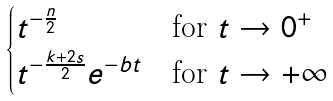<formula> <loc_0><loc_0><loc_500><loc_500>\begin{cases} t ^ { - \frac { n } { 2 } } & \text {for $t \to 0^{+}$} \\ t ^ { - \frac { k + 2 s } { 2 } } e ^ { - b t } & \text {for $t \to +\infty$} \end{cases}</formula> 